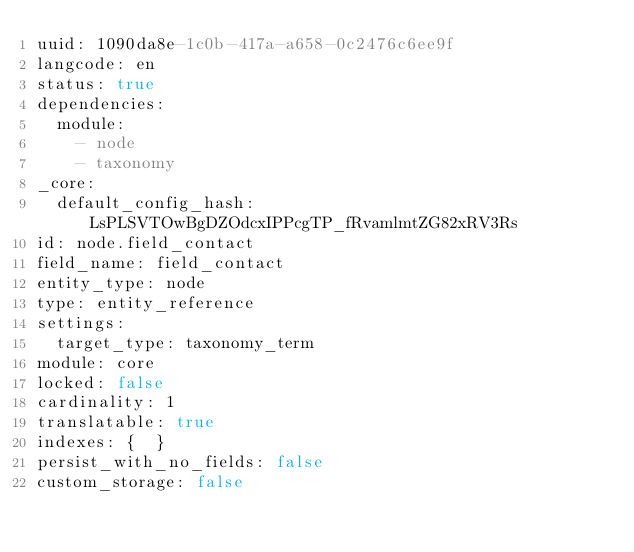Convert code to text. <code><loc_0><loc_0><loc_500><loc_500><_YAML_>uuid: 1090da8e-1c0b-417a-a658-0c2476c6ee9f
langcode: en
status: true
dependencies:
  module:
    - node
    - taxonomy
_core:
  default_config_hash: LsPLSVTOwBgDZOdcxIPPcgTP_fRvamlmtZG82xRV3Rs
id: node.field_contact
field_name: field_contact
entity_type: node
type: entity_reference
settings:
  target_type: taxonomy_term
module: core
locked: false
cardinality: 1
translatable: true
indexes: {  }
persist_with_no_fields: false
custom_storage: false
</code> 